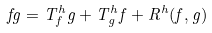<formula> <loc_0><loc_0><loc_500><loc_500>f g = T ^ { h } _ { f } g + T ^ { h } _ { g } f + R ^ { h } ( f , g )</formula> 